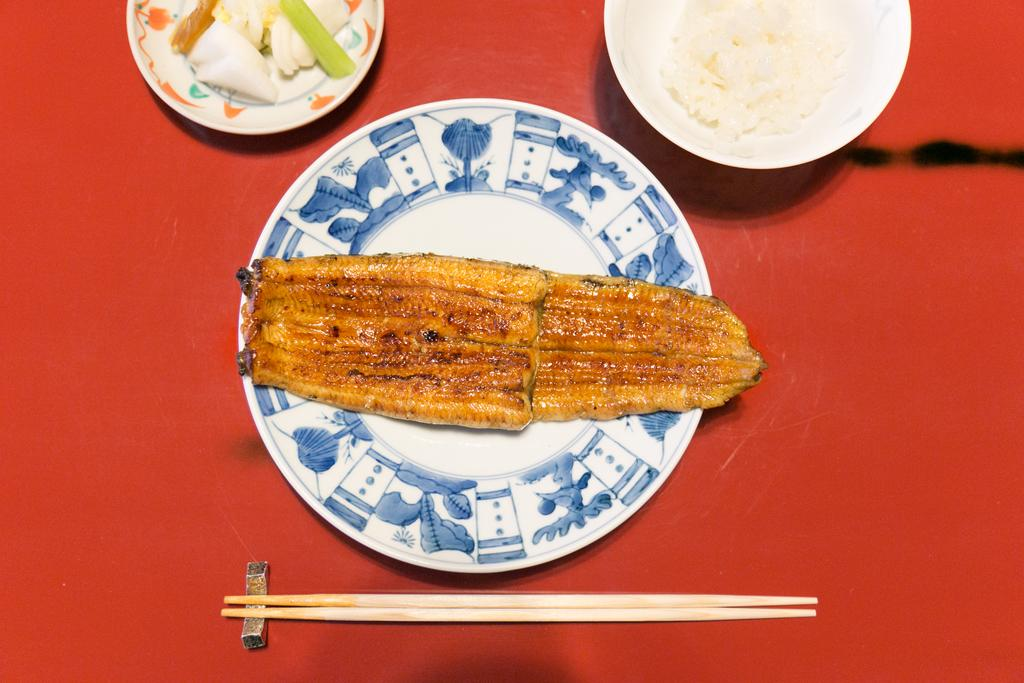What is on the plate that is visible in the image? There is a plate containing food in the image. What utensil is present in the image? Chopsticks are visible in the image. What is in the bowl that is visible in the image? There is a bowl containing rice in the image. What is on the other plate in the image? There is a plate containing eatables in the image. What is the color of the table in the image? The table in the image is red in color. Where is the scarecrow sitting on the swing in the image? There is no scarecrow or swing present in the image. What type of card is being used to eat the food in the image? There is no card present in the image; chopsticks are used to eat the food. 